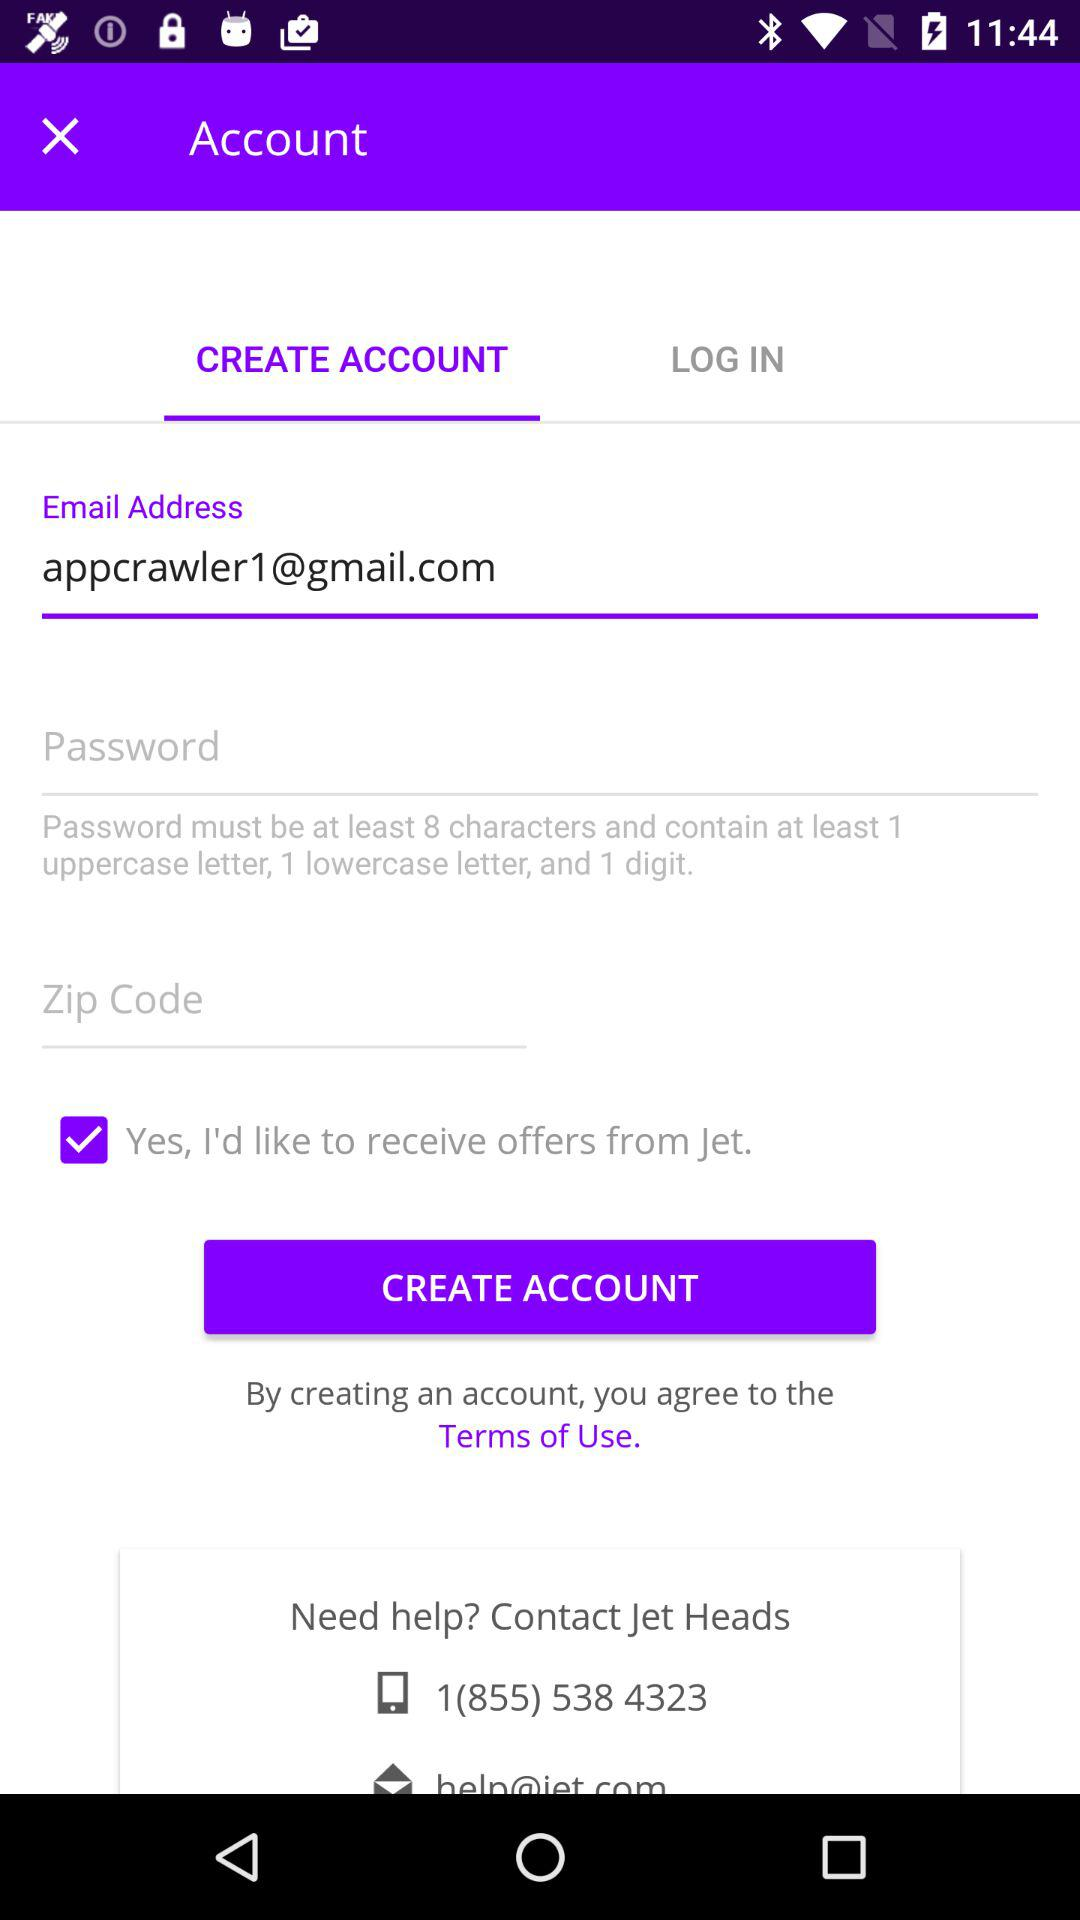What checkbox is selected? The selected checkbox is "Yes, I'd like to receive offers from Jet". 